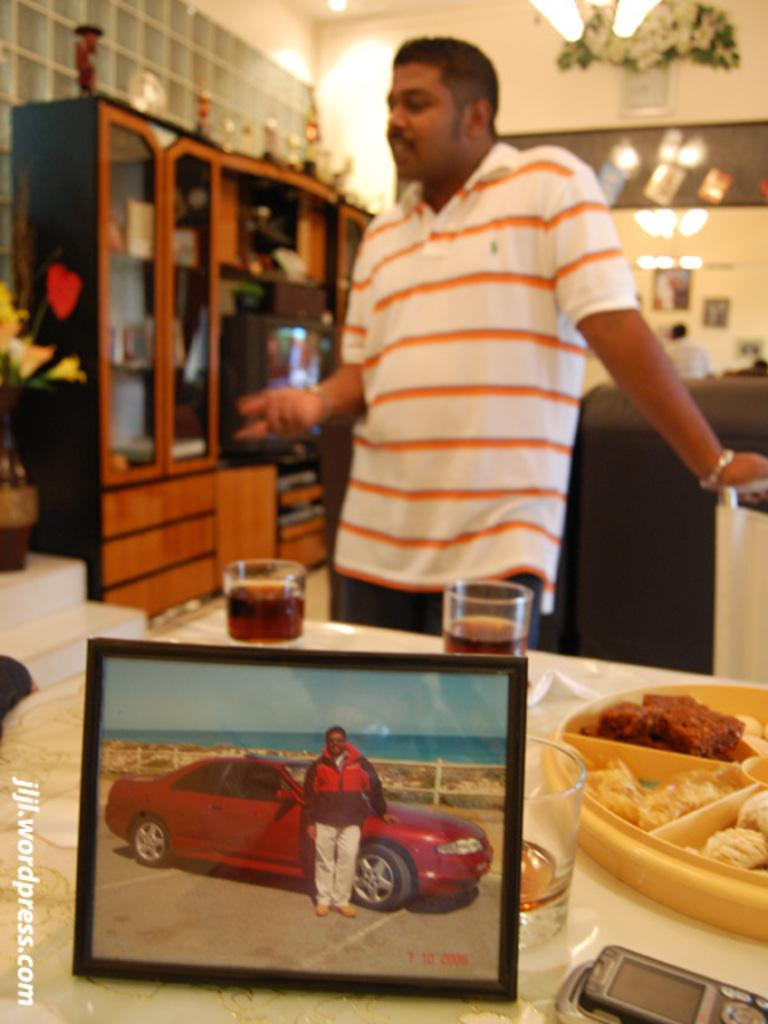What is the main subject of the image? There is a photo in the image. What else can be seen in the image besides the photo? A man is standing near a car, and there is another man standing in the middle of the image. Can you describe the man in the middle? The man in the middle is wearing a t-shirt. What else is present in the image? There are wine glasses on a dining table in the image. What type of brake is the man near the car using in the image? There is no indication in the image that the man near the car is using a brake. Can you tell me how many wires are connected to the wine glasses in the image? There are no wires connected to the wine glasses in the image. 